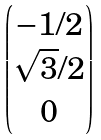<formula> <loc_0><loc_0><loc_500><loc_500>\begin{pmatrix} - 1 / 2 \\ \sqrt { 3 } / 2 \\ 0 \end{pmatrix}</formula> 